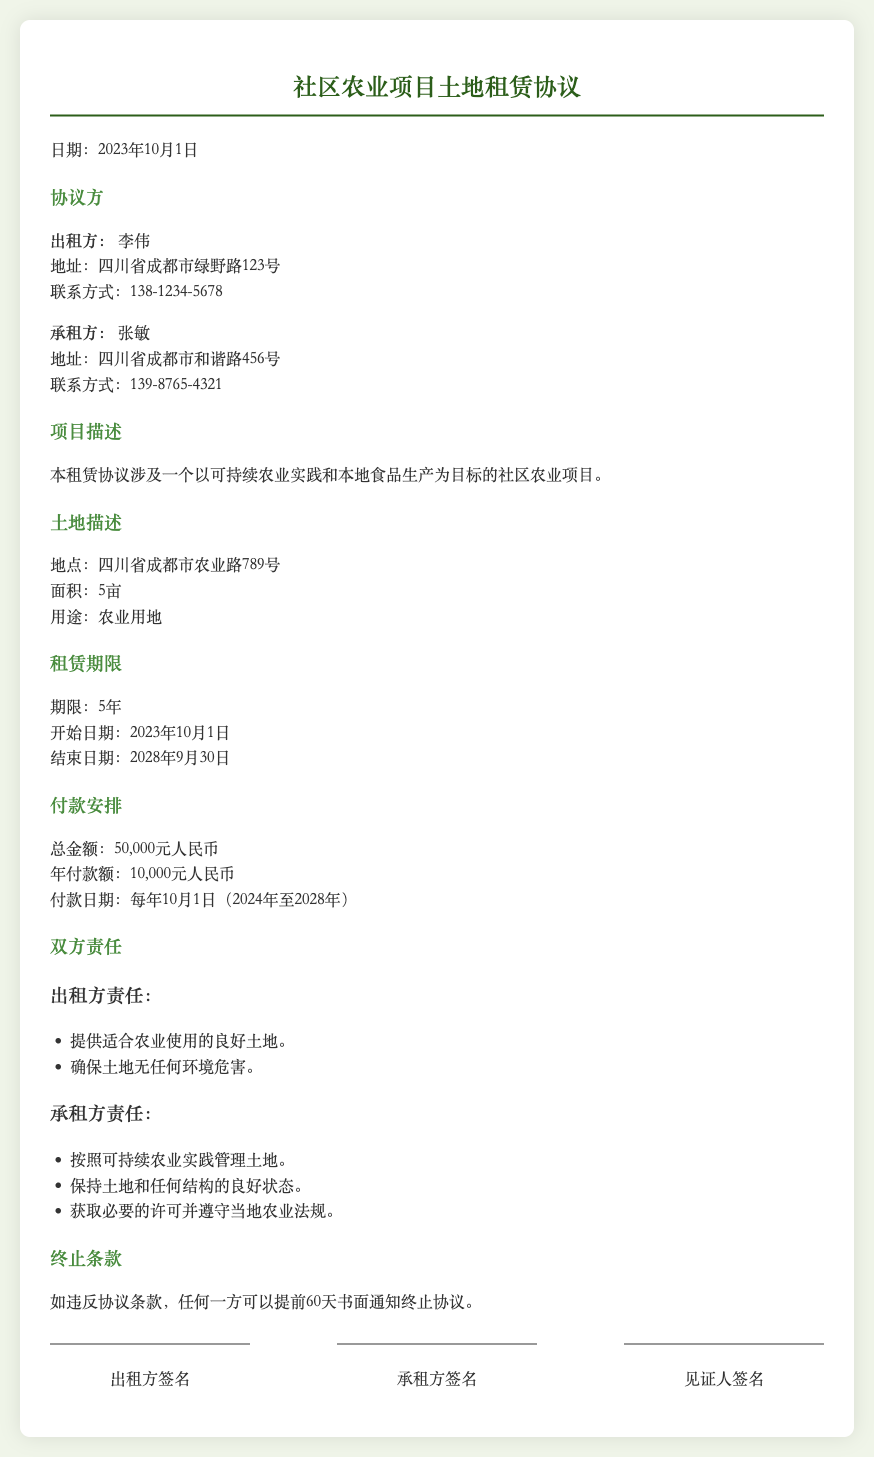租赁方是谁？ 租赁方的信息在文档中是清晰列出的，包括姓名和联系方式。
Answer: 李伟 承租方的地址是什么？ 承租方的地址在文档中详细列出。
Answer: 四川省成都市和谐路456号 租赁地点是哪里？ 租赁的土地位置信息在土地描述部分明确给出。
Answer: 四川省成都市农业路789号 租赁期限是多久？ 租赁期限的具体信息在租赁期限部分列出。
Answer: 5年 年付款额是多少？ 付款安排部分详细列出了年付款额的具体数额。
Answer: 10,000元人民币 如一方违反协议，多久可以终止协议？ 终止条款中提到的具体通知时间明确列出。
Answer: 60天 出租方的责任有哪些？ 出租方责任的内容在文档中以列表形式呈现。
Answer: 提供适合农业使用的良好土地；确保土地无任何环境危害。 承租方的管理责任是？ 承租方责任的内容被清晰列出，以帮助理解其职责。
Answer: 按照可持续农业实践管理土地。 协议签署的日期是什么时候？ 文档开头明确标明了协议的签署日期。
Answer: 2023年10月1日 